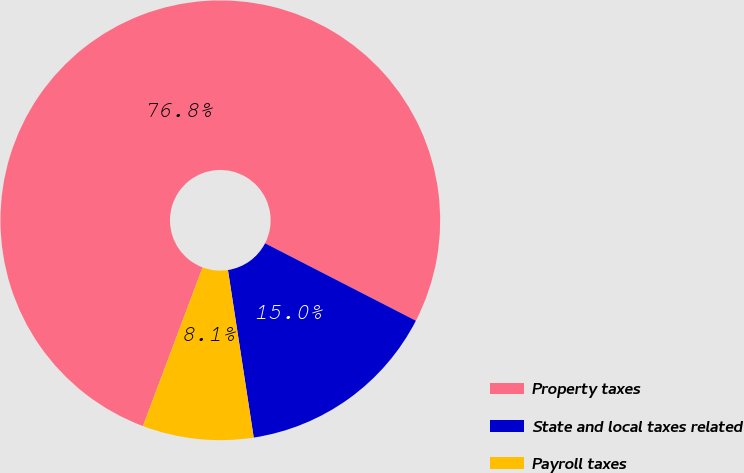Convert chart. <chart><loc_0><loc_0><loc_500><loc_500><pie_chart><fcel>Property taxes<fcel>State and local taxes related<fcel>Payroll taxes<nl><fcel>76.83%<fcel>15.02%<fcel>8.15%<nl></chart> 